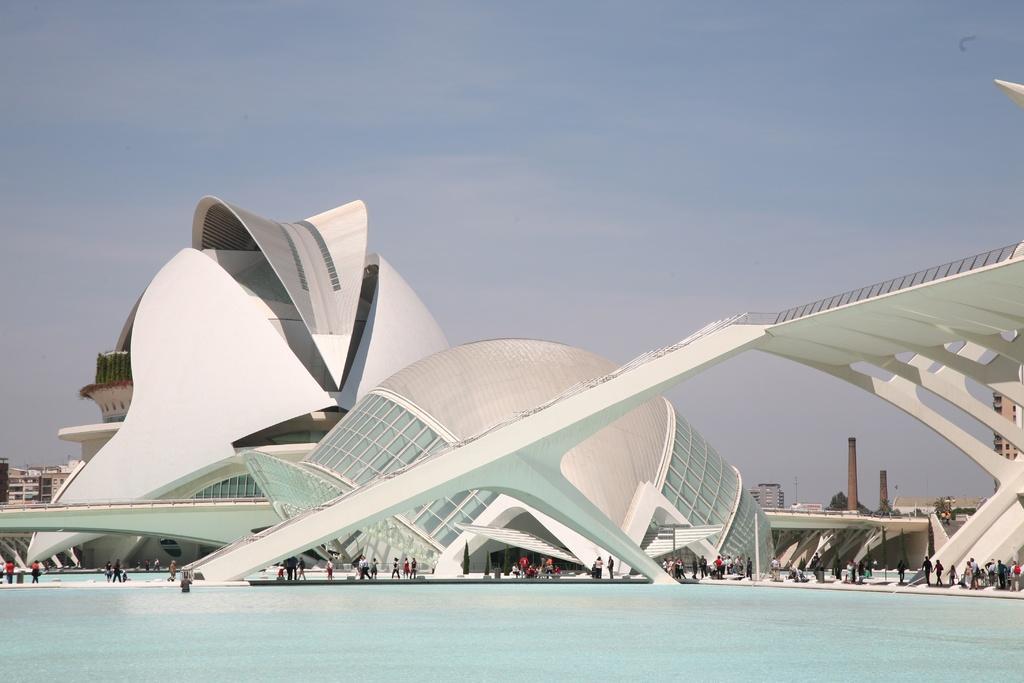Can you describe this image briefly? In this image we can see some buildings. We can also see a group of people standing beside a water body, a tower, some trees and the sky which looks cloudy. 